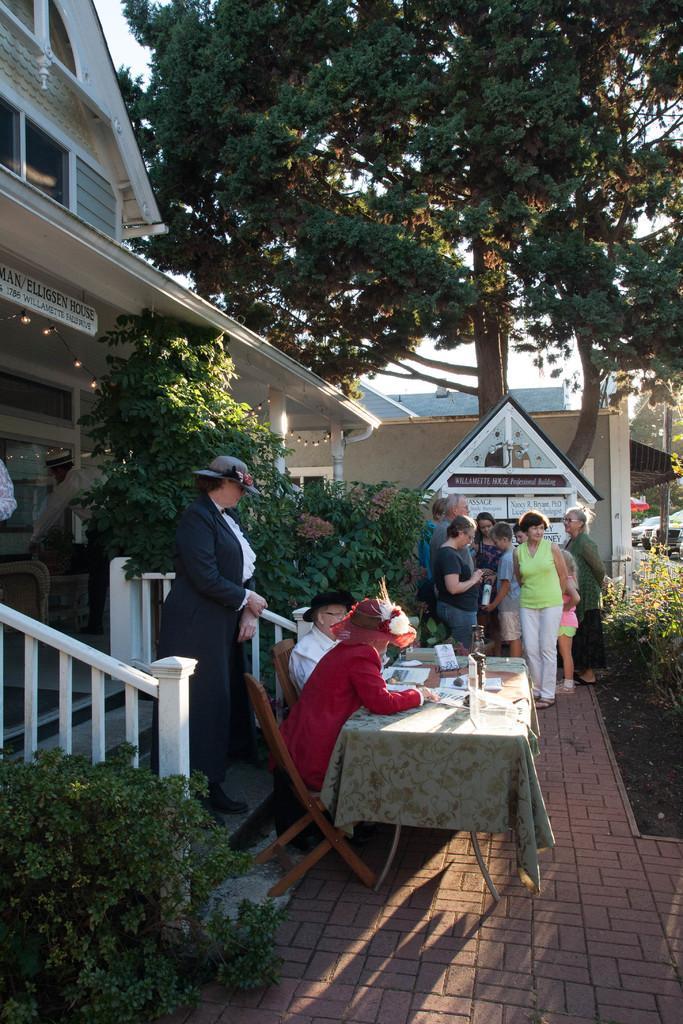Could you give a brief overview of what you see in this image? A house with fence and steps. In-front of this house there are plants. This persons are standing. This 2 persons are sitting on a chair. In-front of this 2 persons there is a table, on a table there are papers. This is a tree. 